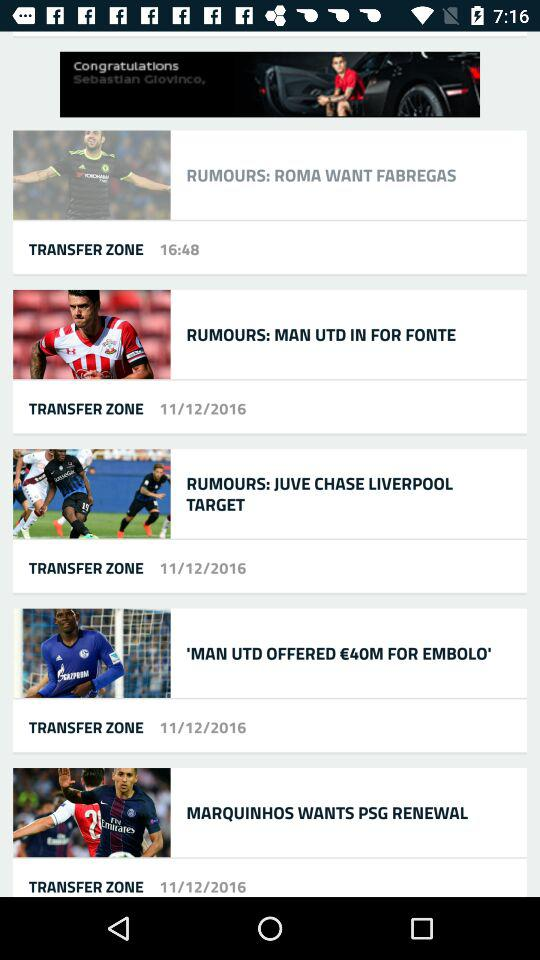On which date is the post "RUMOURS: JUVE CHASE LIVERPOOL TARGET" updated? The post is updated on November 12, 2016. 